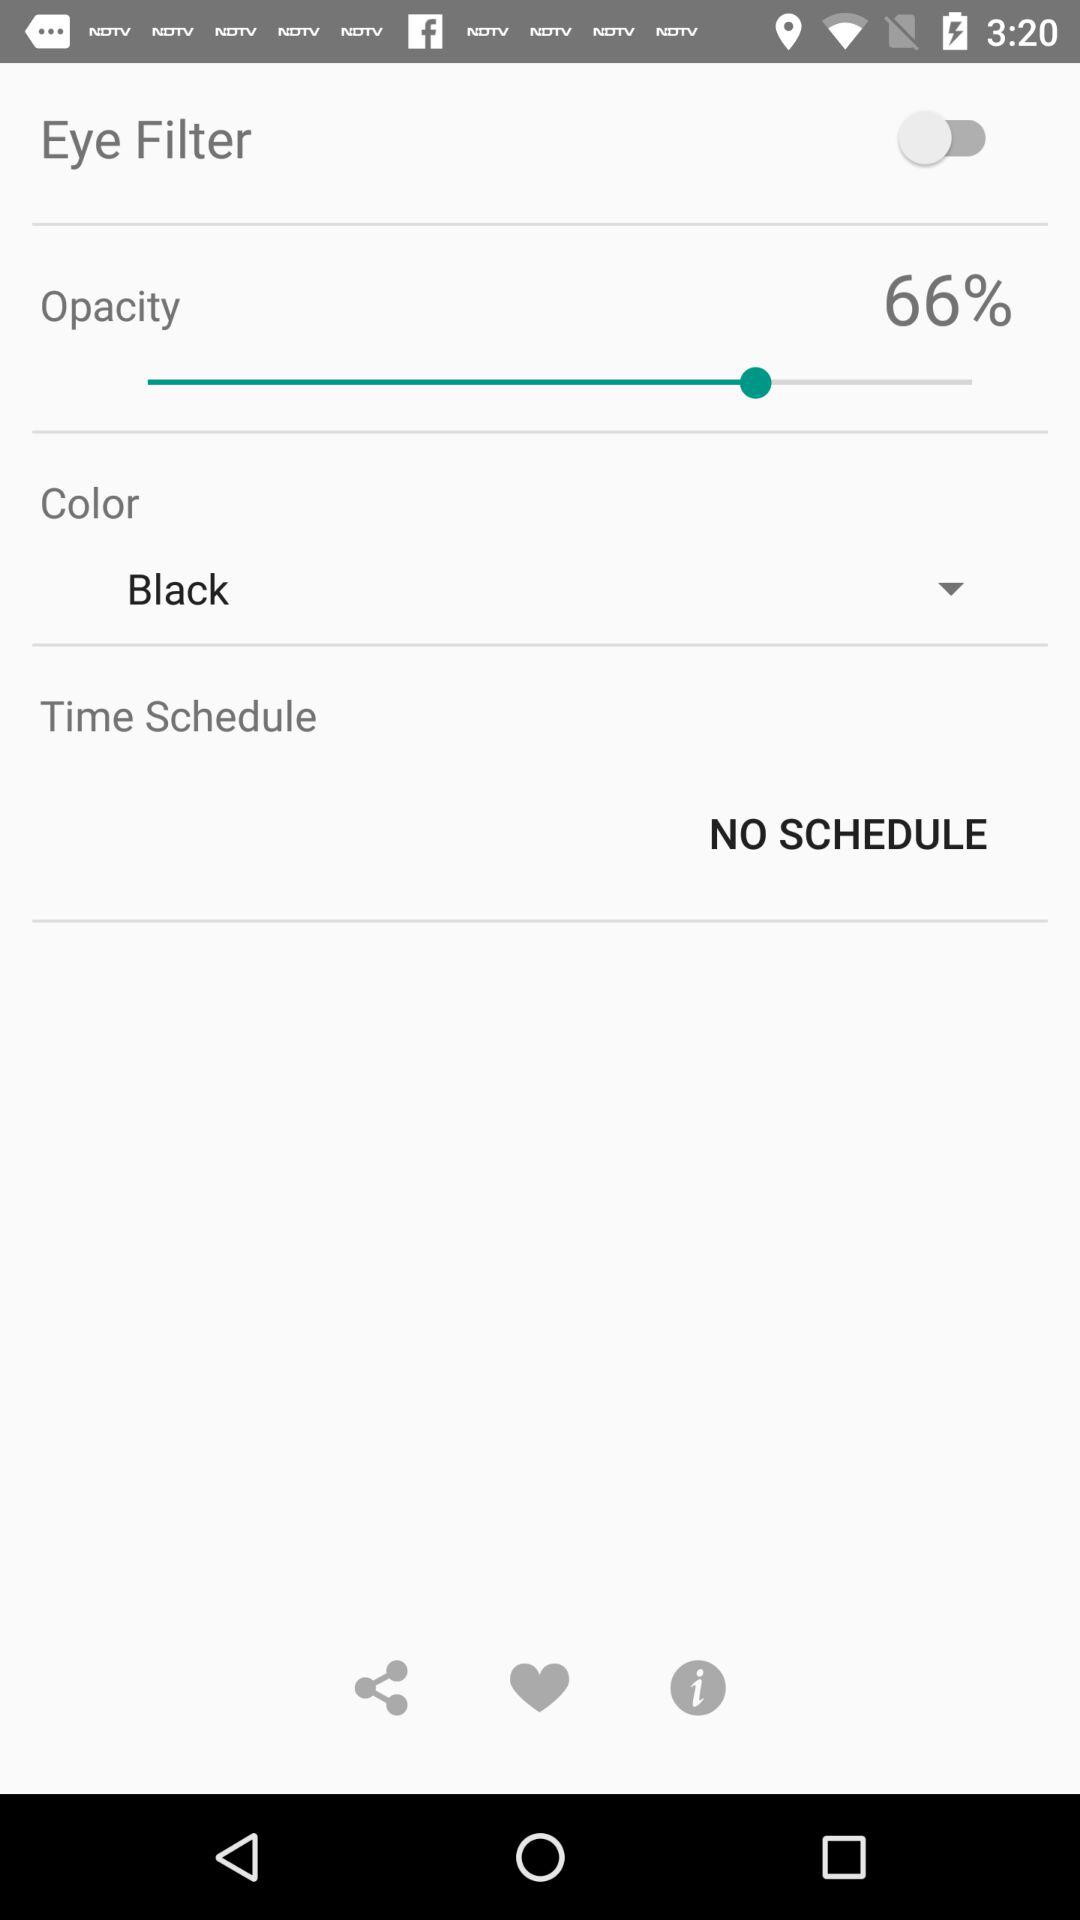What is the status of the "Eye Filter"? The status is "off". 